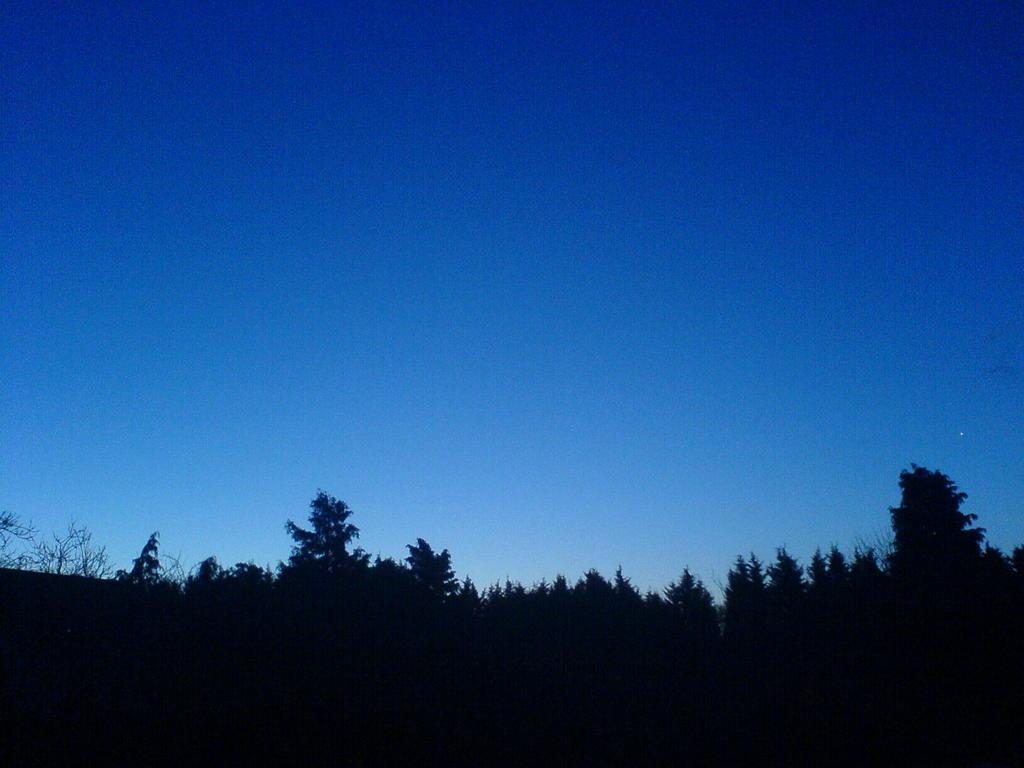Where was the image taken? The image was clicked outside. What can be seen in the foreground of the image? There are trees in the foreground of the image. What is visible in the background of the image? There is a sky visible in the background of the image. Can you see any squirrels or frogs in the image? There is no mention of squirrels or frogs in the image, so we cannot determine their presence. 